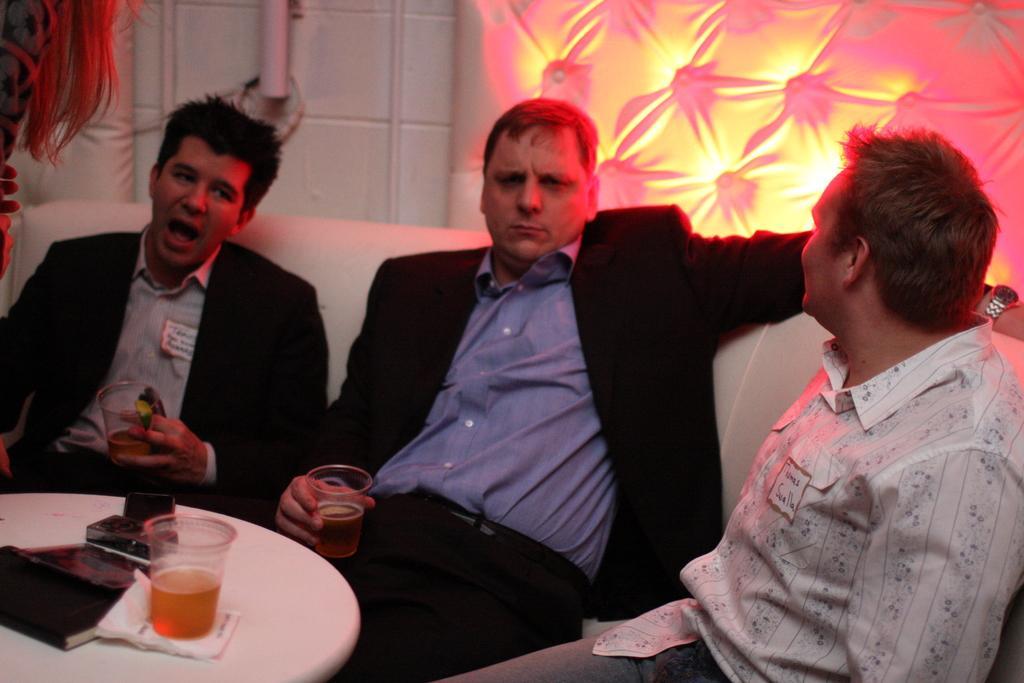Could you give a brief overview of what you see in this image? In this image we can see three persons sitting on the sofa and two of them are holding beverage glasses in their hands. In the background we can see walls, books, tissue papers, table and a beverage glass. 